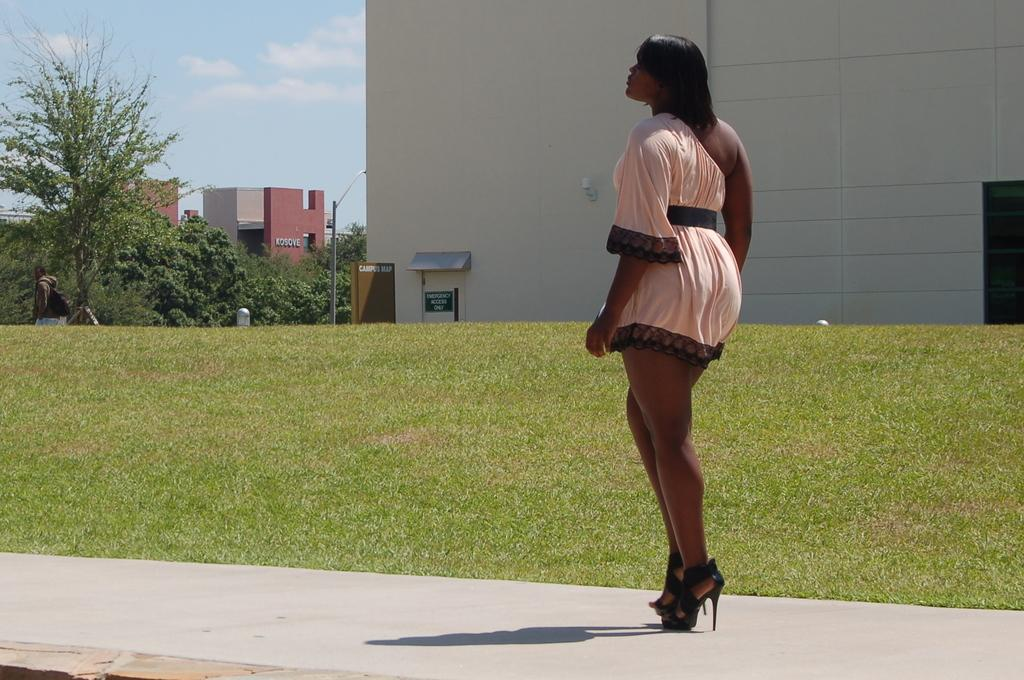What type of vegetation is present in the image? There is grass in the image. What other natural elements can be seen in the image? There are trees in the image. What man-made structures are visible in the image? There are buildings in the image. Can you describe the woman in the image? The woman is wearing a pink dress. What is visible at the top of the image? The sky is visible at the top of the image. What is the condition of the garden in the image? There is no garden present in the image. How many cats can be seen playing in the grass in the image? There are no cats present in the image. 